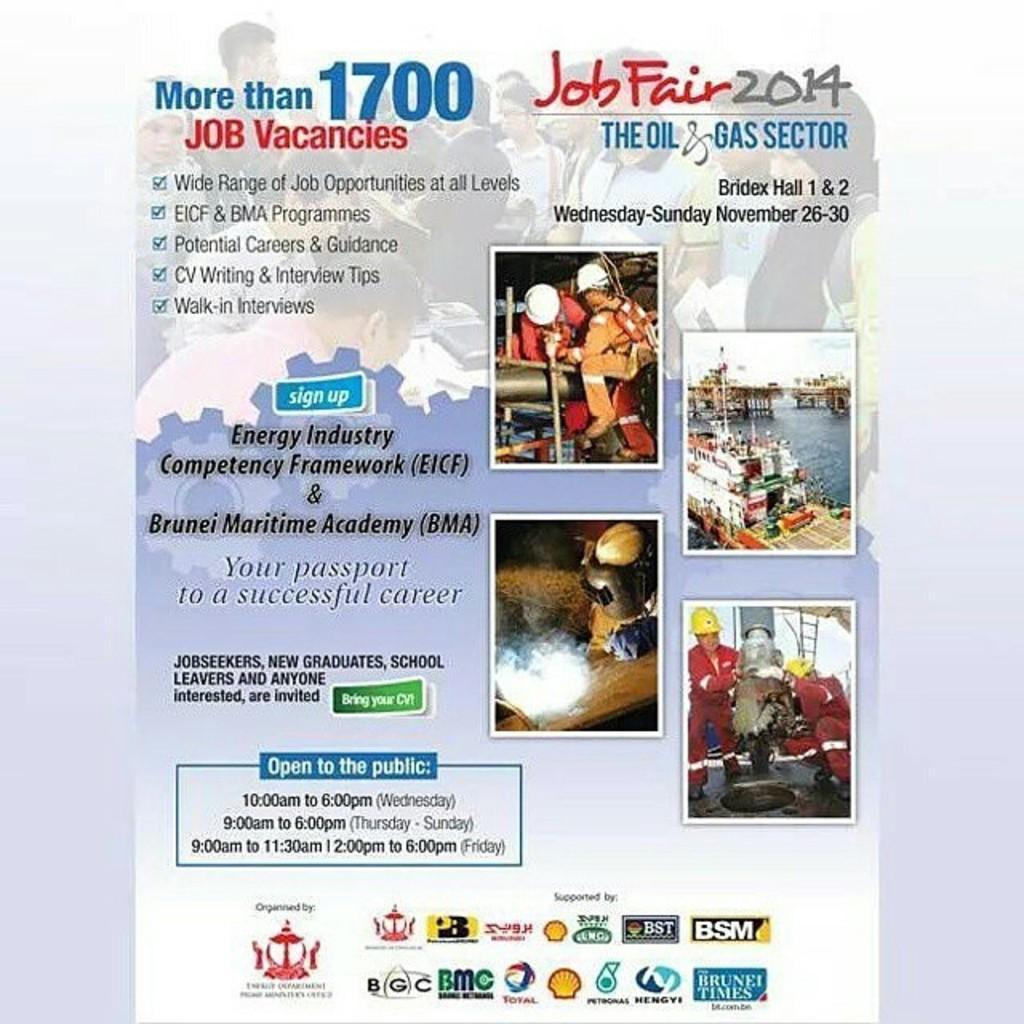How would you summarize this image in a sentence or two? In this image I can see few persons. In front the person is wearing red color dress and yellow color helmet and I can also see the ship on the water. In the ship I can see few people and I can see something written on the image. 